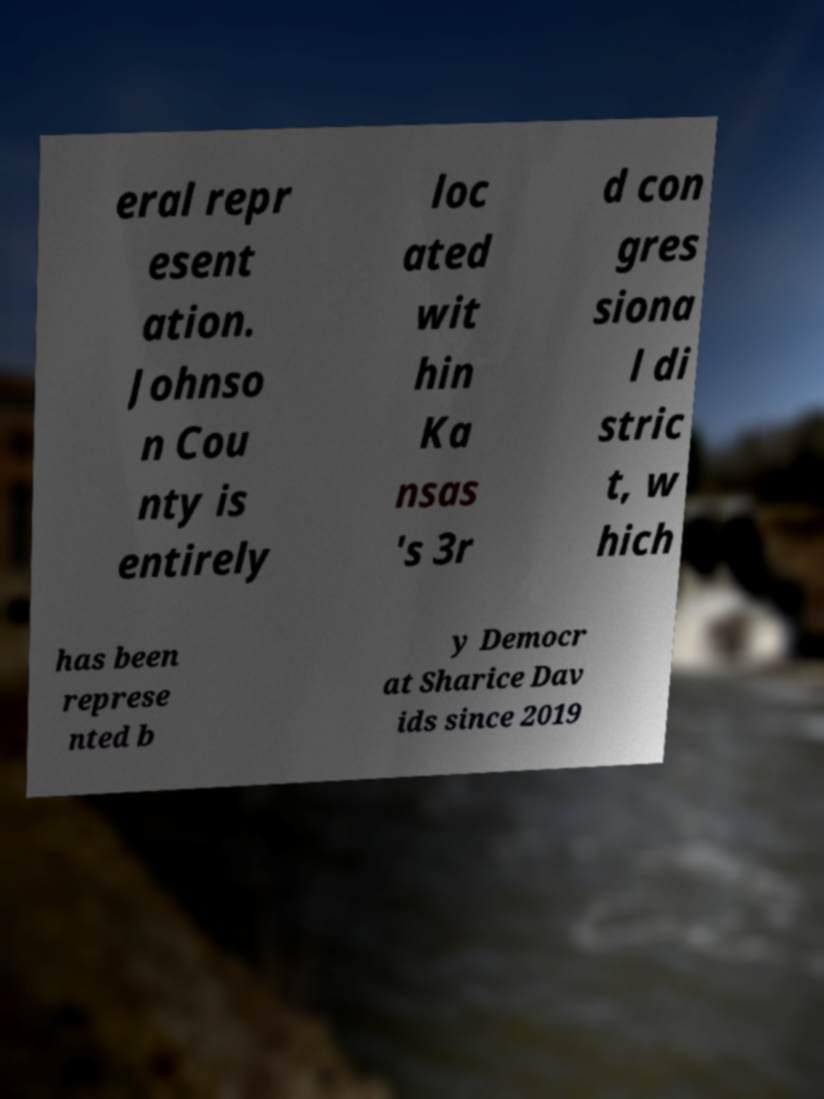There's text embedded in this image that I need extracted. Can you transcribe it verbatim? eral repr esent ation. Johnso n Cou nty is entirely loc ated wit hin Ka nsas 's 3r d con gres siona l di stric t, w hich has been represe nted b y Democr at Sharice Dav ids since 2019 